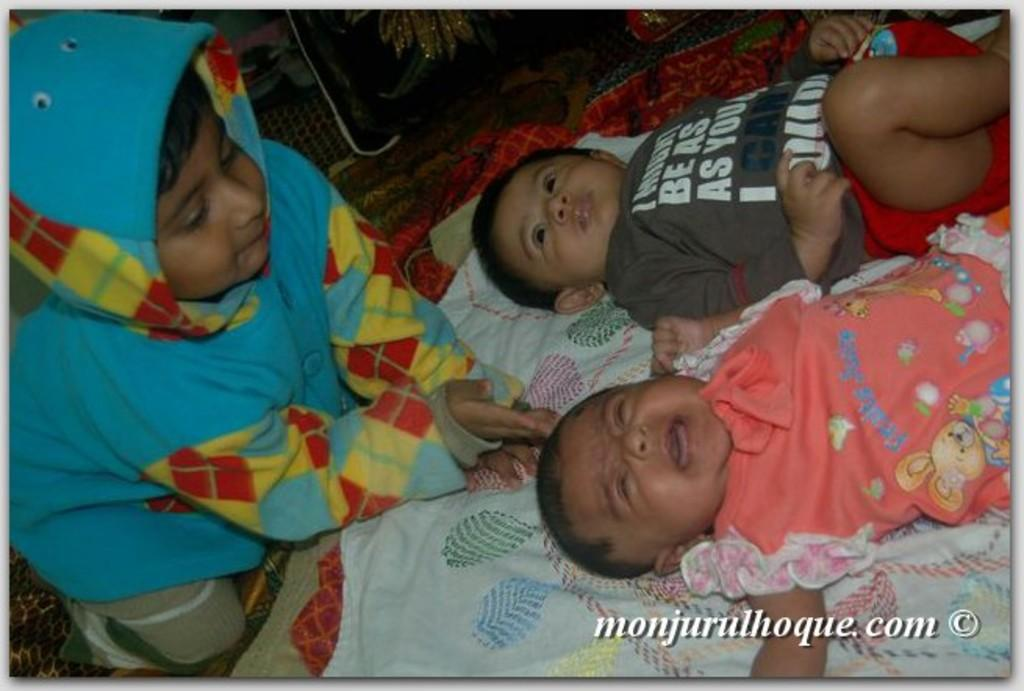How many children are in the image? There are three children in the image. Where are the children located? The children are on a bed. What can be seen behind the children? There are objects visible behind the children. What is written at the bottom of the image? There is text written at the bottom of the image. Where is the sink located in the image? There is no sink present in the image. What type of box can be seen in the image? There is no box present in the image. 